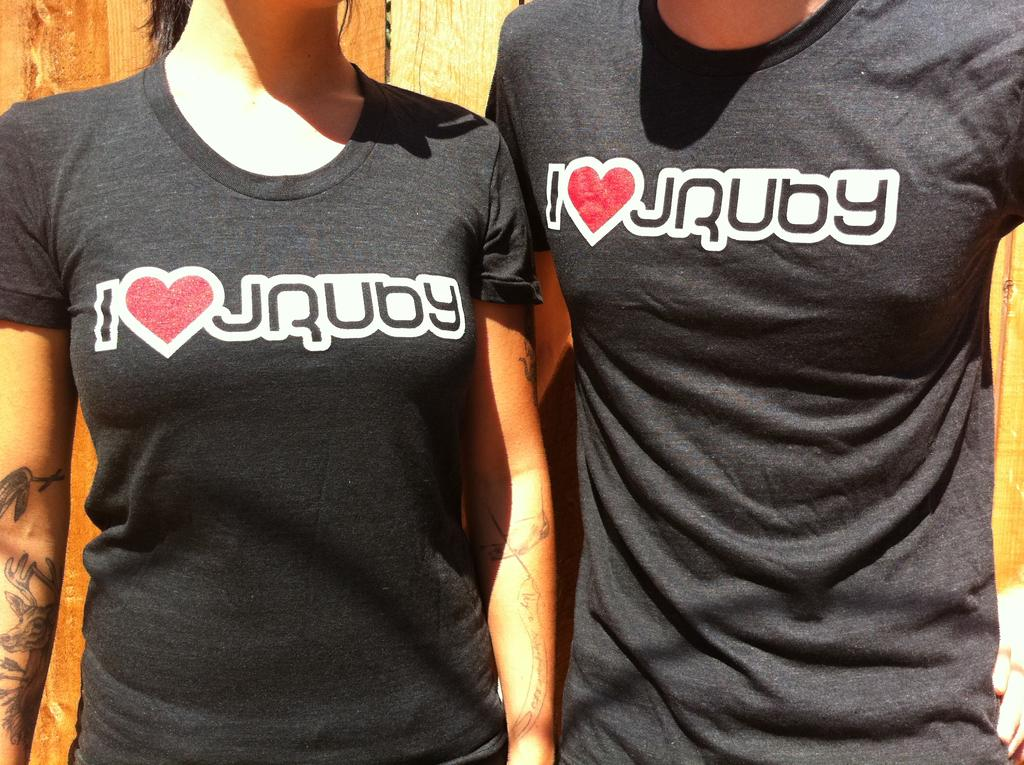Provide a one-sentence caption for the provided image. a faceless man and woman wearing black tshirts that say i <3 jruby. 